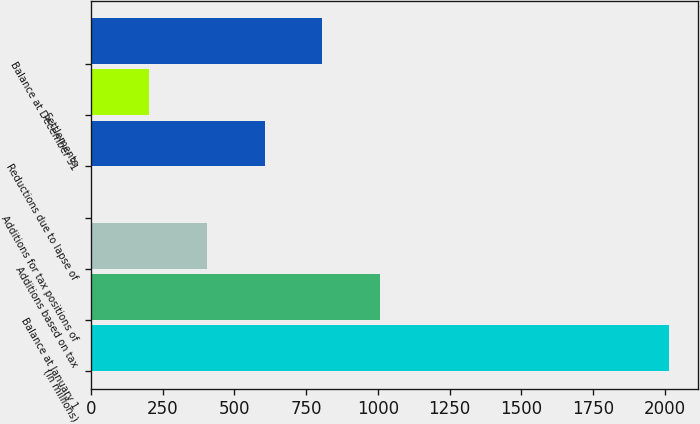<chart> <loc_0><loc_0><loc_500><loc_500><bar_chart><fcel>(in millions)<fcel>Balance at January 1<fcel>Additions based on tax<fcel>Additions for tax positions of<fcel>Reductions due to lapse of<fcel>Settlements<fcel>Balance at December 31<nl><fcel>2016<fcel>1008.5<fcel>404<fcel>1<fcel>605.5<fcel>202.5<fcel>807<nl></chart> 